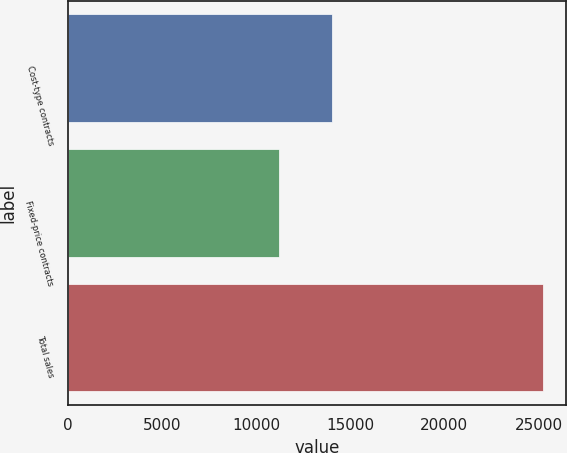<chart> <loc_0><loc_0><loc_500><loc_500><bar_chart><fcel>Cost-type contracts<fcel>Fixed-price contracts<fcel>Total sales<nl><fcel>14015<fcel>11203<fcel>25218<nl></chart> 